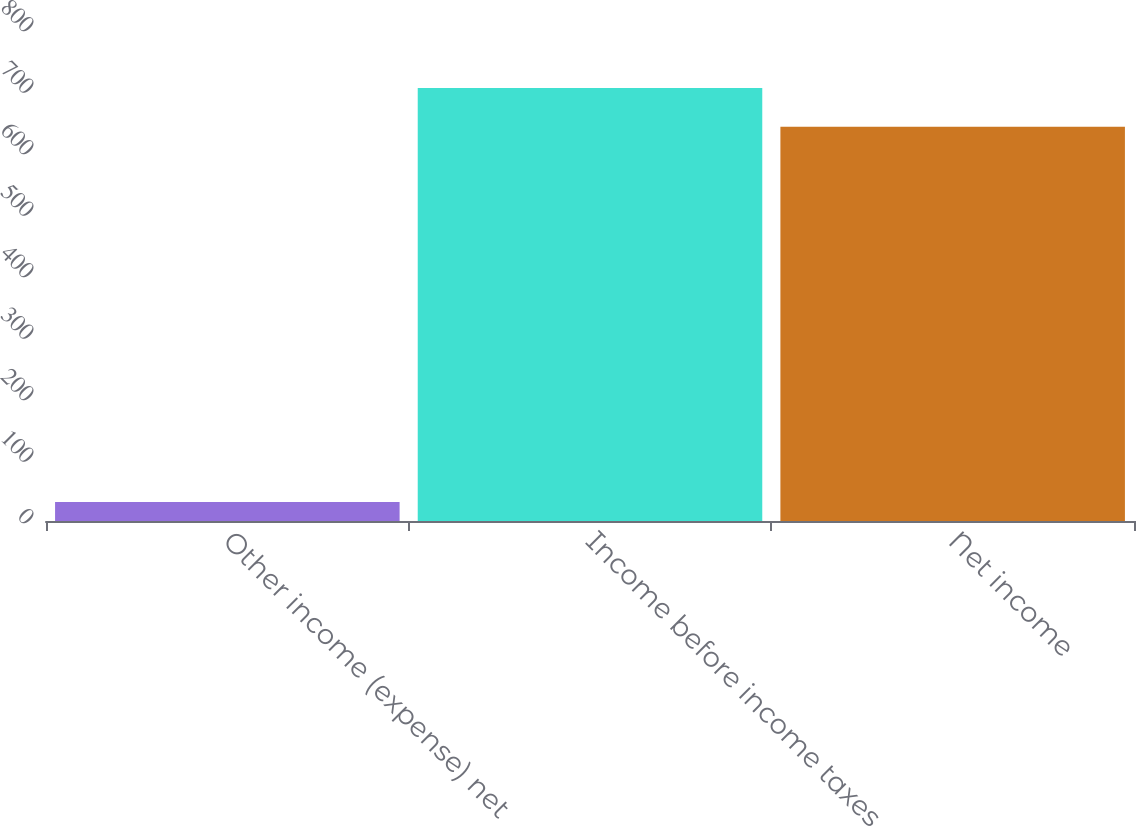Convert chart. <chart><loc_0><loc_0><loc_500><loc_500><bar_chart><fcel>Other income (expense) net<fcel>Income before income taxes<fcel>Net income<nl><fcel>31<fcel>703.9<fcel>641<nl></chart> 